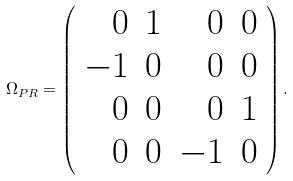Convert formula to latex. <formula><loc_0><loc_0><loc_500><loc_500>\Omega _ { P R } = \left ( \begin{array} { r r r r } 0 & 1 & 0 & 0 \\ - 1 & 0 & 0 & 0 \\ 0 & 0 & 0 & 1 \\ 0 & 0 & - 1 & 0 \end{array} \right ) .</formula> 